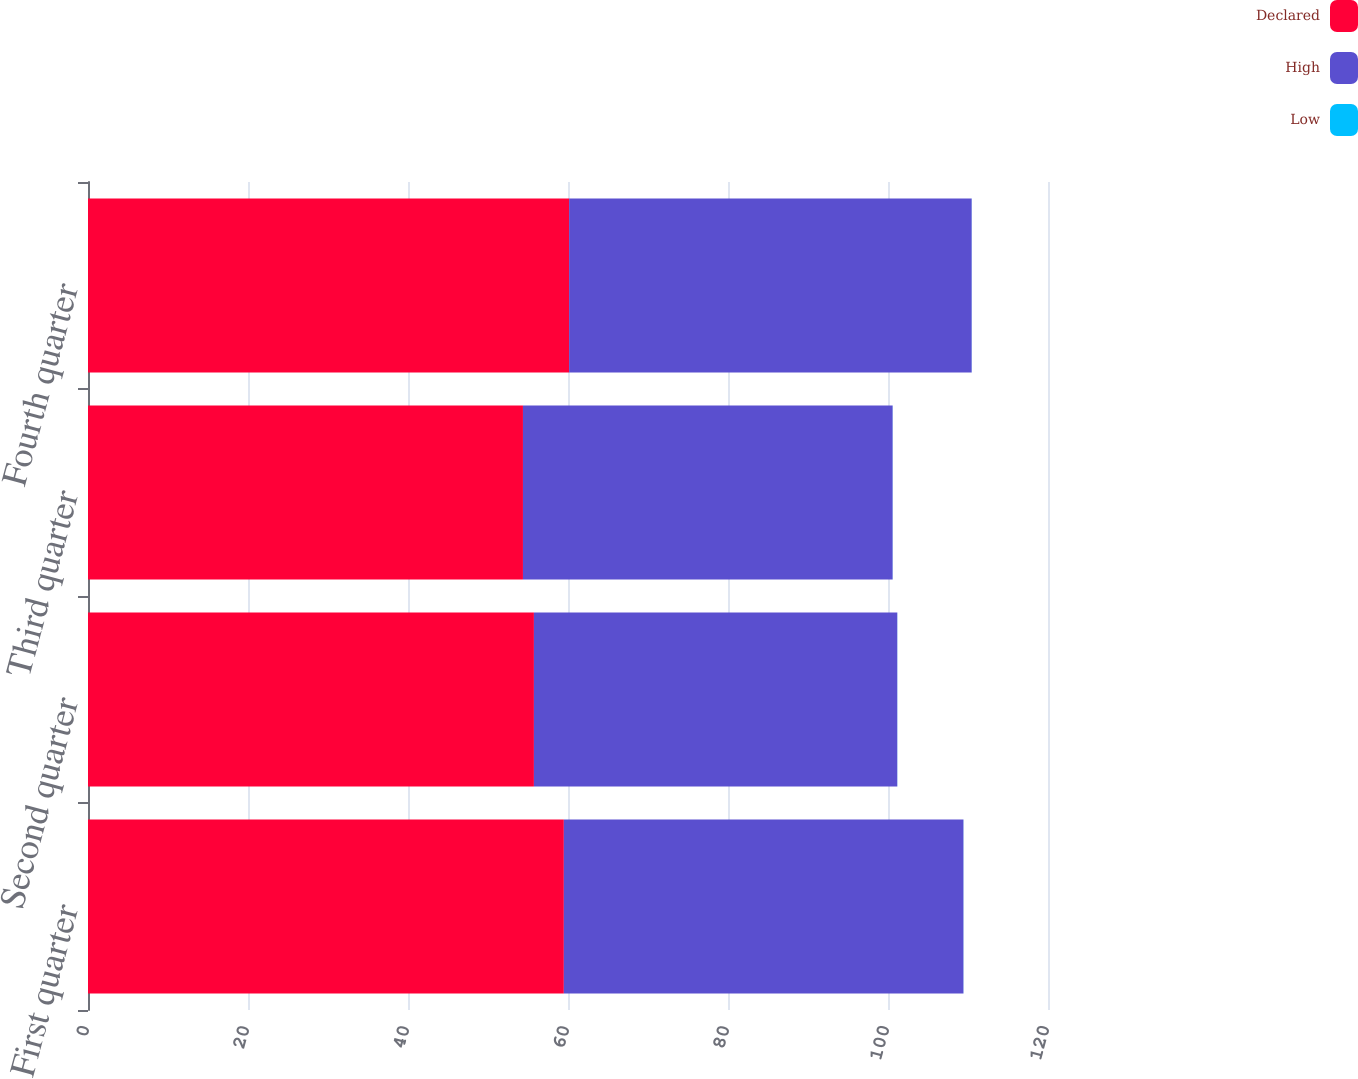Convert chart to OTSL. <chart><loc_0><loc_0><loc_500><loc_500><stacked_bar_chart><ecel><fcel>First quarter<fcel>Second quarter<fcel>Third quarter<fcel>Fourth quarter<nl><fcel>Declared<fcel>59.48<fcel>55.74<fcel>54.37<fcel>60.14<nl><fcel>High<fcel>49.95<fcel>45.42<fcel>46.21<fcel>50.32<nl><fcel>Low<fcel>0.01<fcel>0.01<fcel>0.01<fcel>0.01<nl></chart> 